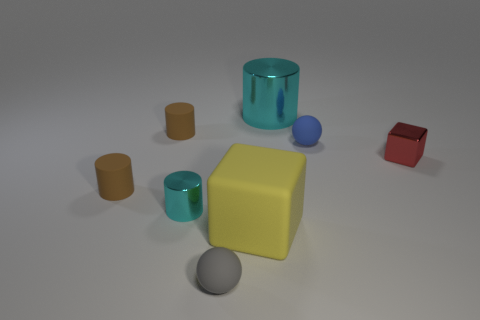There is a cube that is to the left of the large metal cylinder; is there a cylinder that is on the left side of it?
Keep it short and to the point. Yes. Is there anything else that has the same color as the large rubber cube?
Ensure brevity in your answer.  No. Do the cylinder right of the yellow matte thing and the tiny cyan object have the same material?
Your response must be concise. Yes. Are there the same number of big cylinders on the right side of the red shiny object and gray rubber things that are in front of the tiny gray rubber thing?
Ensure brevity in your answer.  Yes. How big is the cube that is to the left of the rubber ball behind the red object?
Give a very brief answer. Large. What is the small thing that is on the right side of the small cyan thing and to the left of the tiny blue rubber sphere made of?
Your answer should be compact. Rubber. How many other things are the same size as the metallic cube?
Provide a short and direct response. 5. The big rubber object is what color?
Your answer should be very brief. Yellow. Do the matte cylinder that is in front of the blue sphere and the small cylinder that is behind the tiny blue object have the same color?
Make the answer very short. Yes. The blue sphere has what size?
Your answer should be very brief. Small. 